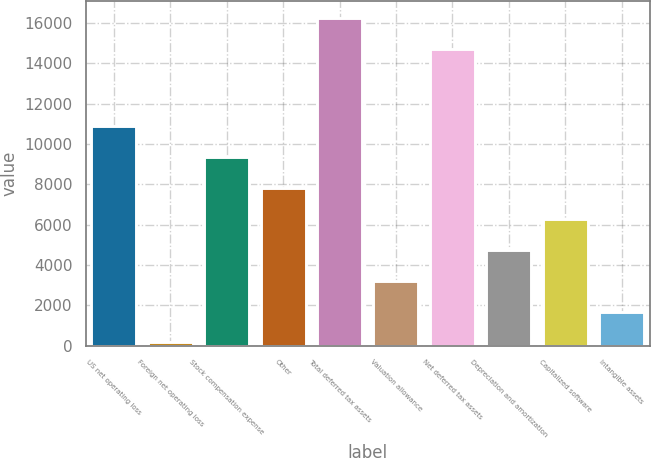<chart> <loc_0><loc_0><loc_500><loc_500><bar_chart><fcel>US net operating loss<fcel>Foreign net operating loss<fcel>Stock compensation expense<fcel>Other<fcel>Total deferred tax assets<fcel>Valuation allowance<fcel>Net deferred tax assets<fcel>Depreciation and amortization<fcel>Capitalized software<fcel>Intangible assets<nl><fcel>10877<fcel>160<fcel>9346<fcel>7815<fcel>16274<fcel>3222<fcel>14743<fcel>4753<fcel>6284<fcel>1691<nl></chart> 